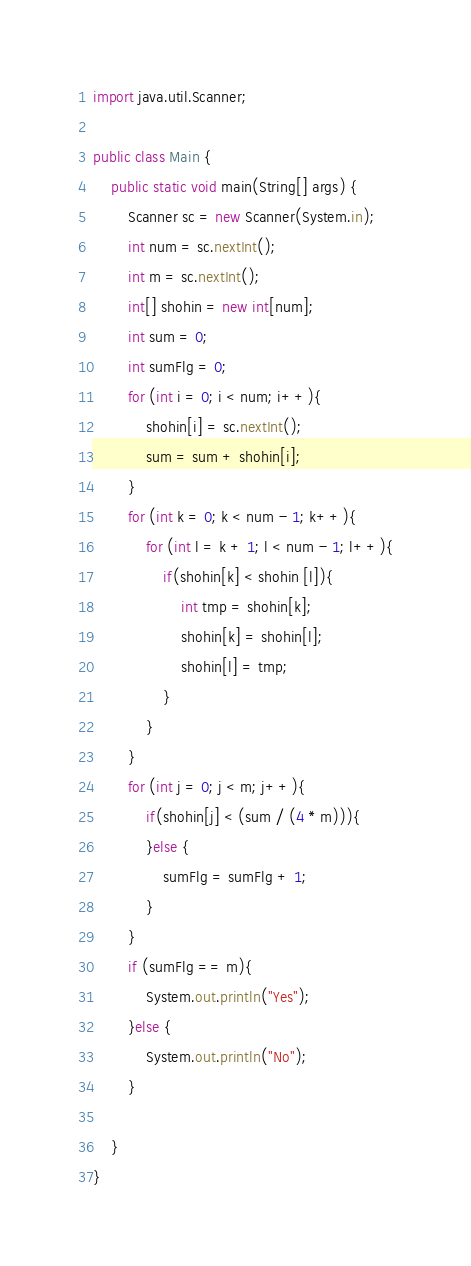<code> <loc_0><loc_0><loc_500><loc_500><_Java_>
import java.util.Scanner;

public class Main {
    public static void main(String[] args) {
        Scanner sc = new Scanner(System.in);
        int num = sc.nextInt();
        int m = sc.nextInt();
        int[] shohin = new int[num];
        int sum = 0;
        int sumFlg = 0;
        for (int i = 0; i < num; i++){
            shohin[i] = sc.nextInt();
            sum = sum + shohin[i];
        }
        for (int k = 0; k < num - 1; k++){
            for (int l = k + 1; l < num - 1; l++){
                if(shohin[k] < shohin [l]){
                    int tmp = shohin[k];
                    shohin[k] = shohin[l];
                    shohin[l] = tmp;
                }
            }
        }
        for (int j = 0; j < m; j++){
            if(shohin[j] < (sum / (4 * m))){
            }else {
                sumFlg = sumFlg + 1;
            }
        }
        if (sumFlg == m){
            System.out.println("Yes");
        }else {
            System.out.println("No");
        }

    }
}
</code> 